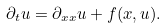Convert formula to latex. <formula><loc_0><loc_0><loc_500><loc_500>\partial _ { t } u = \partial _ { x x } u + f ( x , u ) .</formula> 